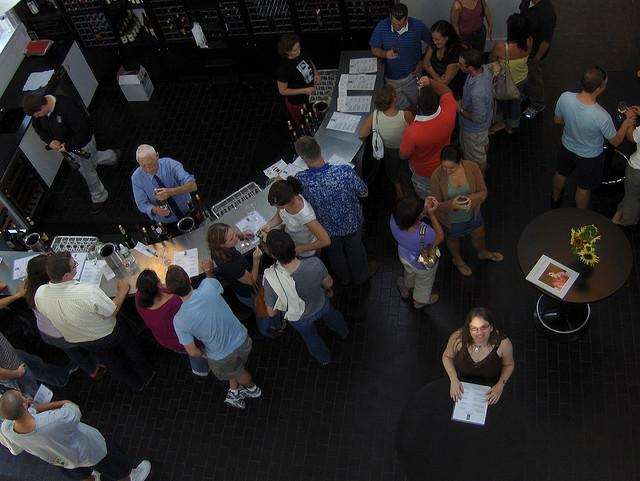What are most people gathered around? counter 